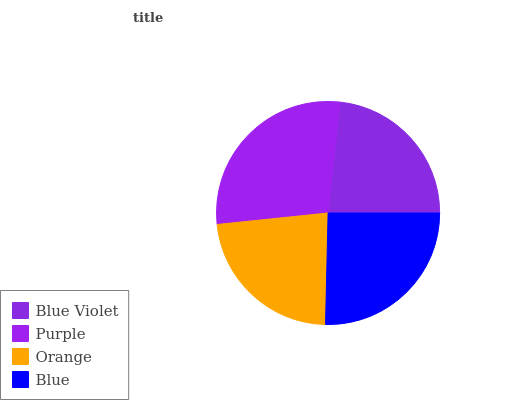Is Orange the minimum?
Answer yes or no. Yes. Is Purple the maximum?
Answer yes or no. Yes. Is Purple the minimum?
Answer yes or no. No. Is Orange the maximum?
Answer yes or no. No. Is Purple greater than Orange?
Answer yes or no. Yes. Is Orange less than Purple?
Answer yes or no. Yes. Is Orange greater than Purple?
Answer yes or no. No. Is Purple less than Orange?
Answer yes or no. No. Is Blue the high median?
Answer yes or no. Yes. Is Blue Violet the low median?
Answer yes or no. Yes. Is Orange the high median?
Answer yes or no. No. Is Blue the low median?
Answer yes or no. No. 